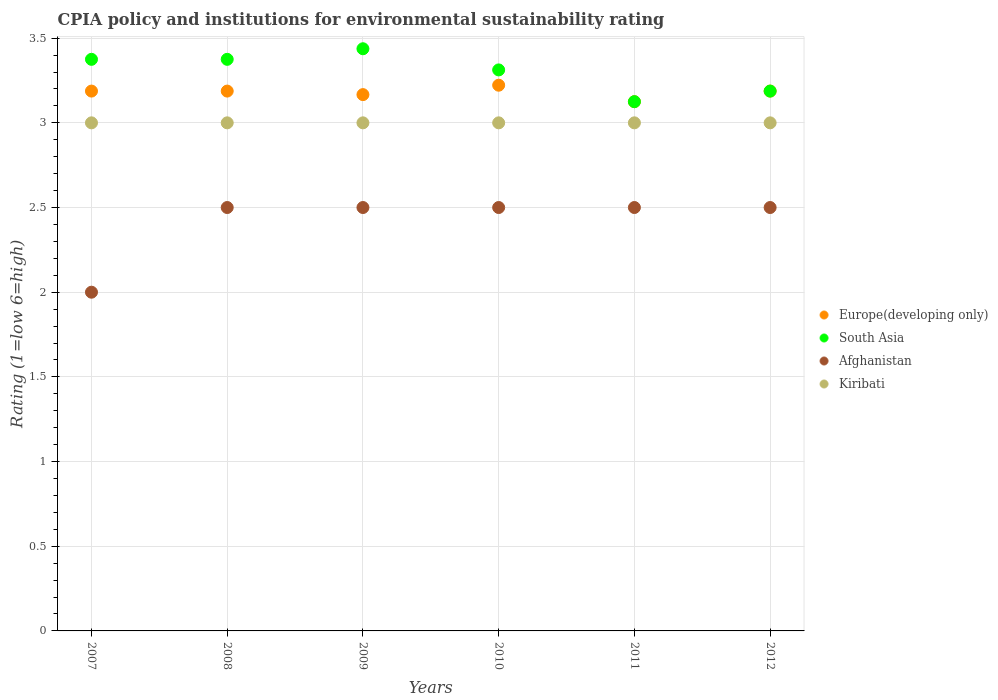What is the CPIA rating in South Asia in 2012?
Provide a succinct answer. 3.19. Across all years, what is the maximum CPIA rating in Afghanistan?
Provide a short and direct response. 2.5. Across all years, what is the minimum CPIA rating in South Asia?
Give a very brief answer. 3.12. In which year was the CPIA rating in South Asia maximum?
Keep it short and to the point. 2009. In which year was the CPIA rating in Kiribati minimum?
Your answer should be compact. 2007. What is the total CPIA rating in Europe(developing only) in the graph?
Your response must be concise. 19.08. What is the difference between the CPIA rating in South Asia in 2008 and that in 2010?
Ensure brevity in your answer.  0.06. What is the difference between the CPIA rating in South Asia in 2011 and the CPIA rating in Europe(developing only) in 2012?
Your answer should be compact. -0.06. What is the average CPIA rating in Europe(developing only) per year?
Provide a succinct answer. 3.18. What is the ratio of the CPIA rating in South Asia in 2010 to that in 2011?
Provide a succinct answer. 1.06. In how many years, is the CPIA rating in Afghanistan greater than the average CPIA rating in Afghanistan taken over all years?
Keep it short and to the point. 5. Is it the case that in every year, the sum of the CPIA rating in Europe(developing only) and CPIA rating in South Asia  is greater than the sum of CPIA rating in Afghanistan and CPIA rating in Kiribati?
Your response must be concise. Yes. Is it the case that in every year, the sum of the CPIA rating in Europe(developing only) and CPIA rating in Kiribati  is greater than the CPIA rating in Afghanistan?
Provide a succinct answer. Yes. Does the CPIA rating in Afghanistan monotonically increase over the years?
Your answer should be very brief. No. Is the CPIA rating in South Asia strictly greater than the CPIA rating in Europe(developing only) over the years?
Your response must be concise. No. Is the CPIA rating in Kiribati strictly less than the CPIA rating in South Asia over the years?
Your answer should be very brief. Yes. What is the difference between two consecutive major ticks on the Y-axis?
Make the answer very short. 0.5. Are the values on the major ticks of Y-axis written in scientific E-notation?
Your response must be concise. No. Where does the legend appear in the graph?
Your answer should be very brief. Center right. What is the title of the graph?
Offer a very short reply. CPIA policy and institutions for environmental sustainability rating. What is the label or title of the X-axis?
Give a very brief answer. Years. What is the label or title of the Y-axis?
Make the answer very short. Rating (1=low 6=high). What is the Rating (1=low 6=high) in Europe(developing only) in 2007?
Your response must be concise. 3.19. What is the Rating (1=low 6=high) of South Asia in 2007?
Provide a short and direct response. 3.38. What is the Rating (1=low 6=high) in Afghanistan in 2007?
Provide a short and direct response. 2. What is the Rating (1=low 6=high) in Kiribati in 2007?
Offer a very short reply. 3. What is the Rating (1=low 6=high) of Europe(developing only) in 2008?
Your answer should be very brief. 3.19. What is the Rating (1=low 6=high) in South Asia in 2008?
Make the answer very short. 3.38. What is the Rating (1=low 6=high) in Kiribati in 2008?
Provide a short and direct response. 3. What is the Rating (1=low 6=high) in Europe(developing only) in 2009?
Your answer should be compact. 3.17. What is the Rating (1=low 6=high) in South Asia in 2009?
Your response must be concise. 3.44. What is the Rating (1=low 6=high) of Kiribati in 2009?
Offer a very short reply. 3. What is the Rating (1=low 6=high) in Europe(developing only) in 2010?
Offer a terse response. 3.22. What is the Rating (1=low 6=high) of South Asia in 2010?
Keep it short and to the point. 3.31. What is the Rating (1=low 6=high) in Europe(developing only) in 2011?
Keep it short and to the point. 3.12. What is the Rating (1=low 6=high) in South Asia in 2011?
Your response must be concise. 3.12. What is the Rating (1=low 6=high) in Afghanistan in 2011?
Provide a succinct answer. 2.5. What is the Rating (1=low 6=high) in Kiribati in 2011?
Provide a short and direct response. 3. What is the Rating (1=low 6=high) of Europe(developing only) in 2012?
Offer a terse response. 3.19. What is the Rating (1=low 6=high) in South Asia in 2012?
Offer a very short reply. 3.19. What is the Rating (1=low 6=high) in Kiribati in 2012?
Ensure brevity in your answer.  3. Across all years, what is the maximum Rating (1=low 6=high) in Europe(developing only)?
Give a very brief answer. 3.22. Across all years, what is the maximum Rating (1=low 6=high) of South Asia?
Ensure brevity in your answer.  3.44. Across all years, what is the maximum Rating (1=low 6=high) of Kiribati?
Make the answer very short. 3. Across all years, what is the minimum Rating (1=low 6=high) of Europe(developing only)?
Ensure brevity in your answer.  3.12. Across all years, what is the minimum Rating (1=low 6=high) of South Asia?
Give a very brief answer. 3.12. What is the total Rating (1=low 6=high) of Europe(developing only) in the graph?
Keep it short and to the point. 19.08. What is the total Rating (1=low 6=high) in South Asia in the graph?
Offer a very short reply. 19.81. What is the difference between the Rating (1=low 6=high) of Europe(developing only) in 2007 and that in 2008?
Give a very brief answer. 0. What is the difference between the Rating (1=low 6=high) in South Asia in 2007 and that in 2008?
Provide a succinct answer. 0. What is the difference between the Rating (1=low 6=high) in Afghanistan in 2007 and that in 2008?
Provide a short and direct response. -0.5. What is the difference between the Rating (1=low 6=high) of Kiribati in 2007 and that in 2008?
Provide a short and direct response. 0. What is the difference between the Rating (1=low 6=high) of Europe(developing only) in 2007 and that in 2009?
Keep it short and to the point. 0.02. What is the difference between the Rating (1=low 6=high) of South Asia in 2007 and that in 2009?
Ensure brevity in your answer.  -0.06. What is the difference between the Rating (1=low 6=high) of Kiribati in 2007 and that in 2009?
Offer a terse response. 0. What is the difference between the Rating (1=low 6=high) of Europe(developing only) in 2007 and that in 2010?
Offer a terse response. -0.03. What is the difference between the Rating (1=low 6=high) in South Asia in 2007 and that in 2010?
Offer a very short reply. 0.06. What is the difference between the Rating (1=low 6=high) in Kiribati in 2007 and that in 2010?
Keep it short and to the point. 0. What is the difference between the Rating (1=low 6=high) of Europe(developing only) in 2007 and that in 2011?
Offer a terse response. 0.06. What is the difference between the Rating (1=low 6=high) of South Asia in 2007 and that in 2012?
Offer a terse response. 0.19. What is the difference between the Rating (1=low 6=high) of Afghanistan in 2007 and that in 2012?
Offer a terse response. -0.5. What is the difference between the Rating (1=low 6=high) of Kiribati in 2007 and that in 2012?
Offer a very short reply. 0. What is the difference between the Rating (1=low 6=high) in Europe(developing only) in 2008 and that in 2009?
Your answer should be very brief. 0.02. What is the difference between the Rating (1=low 6=high) of South Asia in 2008 and that in 2009?
Offer a terse response. -0.06. What is the difference between the Rating (1=low 6=high) in Europe(developing only) in 2008 and that in 2010?
Your answer should be very brief. -0.03. What is the difference between the Rating (1=low 6=high) in South Asia in 2008 and that in 2010?
Your response must be concise. 0.06. What is the difference between the Rating (1=low 6=high) of Kiribati in 2008 and that in 2010?
Your response must be concise. 0. What is the difference between the Rating (1=low 6=high) in Europe(developing only) in 2008 and that in 2011?
Keep it short and to the point. 0.06. What is the difference between the Rating (1=low 6=high) of Kiribati in 2008 and that in 2011?
Give a very brief answer. 0. What is the difference between the Rating (1=low 6=high) of Europe(developing only) in 2008 and that in 2012?
Keep it short and to the point. 0. What is the difference between the Rating (1=low 6=high) in South Asia in 2008 and that in 2012?
Give a very brief answer. 0.19. What is the difference between the Rating (1=low 6=high) in Kiribati in 2008 and that in 2012?
Your answer should be compact. 0. What is the difference between the Rating (1=low 6=high) of Europe(developing only) in 2009 and that in 2010?
Your response must be concise. -0.06. What is the difference between the Rating (1=low 6=high) in South Asia in 2009 and that in 2010?
Your answer should be very brief. 0.12. What is the difference between the Rating (1=low 6=high) in Kiribati in 2009 and that in 2010?
Make the answer very short. 0. What is the difference between the Rating (1=low 6=high) in Europe(developing only) in 2009 and that in 2011?
Ensure brevity in your answer.  0.04. What is the difference between the Rating (1=low 6=high) in South Asia in 2009 and that in 2011?
Offer a very short reply. 0.31. What is the difference between the Rating (1=low 6=high) in Kiribati in 2009 and that in 2011?
Your answer should be very brief. 0. What is the difference between the Rating (1=low 6=high) of Europe(developing only) in 2009 and that in 2012?
Offer a very short reply. -0.02. What is the difference between the Rating (1=low 6=high) in Afghanistan in 2009 and that in 2012?
Provide a succinct answer. 0. What is the difference between the Rating (1=low 6=high) in Europe(developing only) in 2010 and that in 2011?
Offer a very short reply. 0.1. What is the difference between the Rating (1=low 6=high) in South Asia in 2010 and that in 2011?
Your response must be concise. 0.19. What is the difference between the Rating (1=low 6=high) in Kiribati in 2010 and that in 2011?
Make the answer very short. 0. What is the difference between the Rating (1=low 6=high) in Europe(developing only) in 2010 and that in 2012?
Provide a short and direct response. 0.03. What is the difference between the Rating (1=low 6=high) of South Asia in 2010 and that in 2012?
Provide a short and direct response. 0.12. What is the difference between the Rating (1=low 6=high) in Kiribati in 2010 and that in 2012?
Keep it short and to the point. 0. What is the difference between the Rating (1=low 6=high) of Europe(developing only) in 2011 and that in 2012?
Provide a short and direct response. -0.06. What is the difference between the Rating (1=low 6=high) in South Asia in 2011 and that in 2012?
Provide a succinct answer. -0.06. What is the difference between the Rating (1=low 6=high) in Europe(developing only) in 2007 and the Rating (1=low 6=high) in South Asia in 2008?
Give a very brief answer. -0.19. What is the difference between the Rating (1=low 6=high) of Europe(developing only) in 2007 and the Rating (1=low 6=high) of Afghanistan in 2008?
Your answer should be very brief. 0.69. What is the difference between the Rating (1=low 6=high) in Europe(developing only) in 2007 and the Rating (1=low 6=high) in Kiribati in 2008?
Make the answer very short. 0.19. What is the difference between the Rating (1=low 6=high) of Afghanistan in 2007 and the Rating (1=low 6=high) of Kiribati in 2008?
Offer a very short reply. -1. What is the difference between the Rating (1=low 6=high) in Europe(developing only) in 2007 and the Rating (1=low 6=high) in South Asia in 2009?
Provide a short and direct response. -0.25. What is the difference between the Rating (1=low 6=high) of Europe(developing only) in 2007 and the Rating (1=low 6=high) of Afghanistan in 2009?
Your response must be concise. 0.69. What is the difference between the Rating (1=low 6=high) in Europe(developing only) in 2007 and the Rating (1=low 6=high) in Kiribati in 2009?
Offer a very short reply. 0.19. What is the difference between the Rating (1=low 6=high) in Afghanistan in 2007 and the Rating (1=low 6=high) in Kiribati in 2009?
Offer a very short reply. -1. What is the difference between the Rating (1=low 6=high) of Europe(developing only) in 2007 and the Rating (1=low 6=high) of South Asia in 2010?
Offer a very short reply. -0.12. What is the difference between the Rating (1=low 6=high) of Europe(developing only) in 2007 and the Rating (1=low 6=high) of Afghanistan in 2010?
Your answer should be very brief. 0.69. What is the difference between the Rating (1=low 6=high) in Europe(developing only) in 2007 and the Rating (1=low 6=high) in Kiribati in 2010?
Give a very brief answer. 0.19. What is the difference between the Rating (1=low 6=high) of South Asia in 2007 and the Rating (1=low 6=high) of Afghanistan in 2010?
Provide a succinct answer. 0.88. What is the difference between the Rating (1=low 6=high) in South Asia in 2007 and the Rating (1=low 6=high) in Kiribati in 2010?
Your response must be concise. 0.38. What is the difference between the Rating (1=low 6=high) of Europe(developing only) in 2007 and the Rating (1=low 6=high) of South Asia in 2011?
Provide a succinct answer. 0.06. What is the difference between the Rating (1=low 6=high) in Europe(developing only) in 2007 and the Rating (1=low 6=high) in Afghanistan in 2011?
Offer a very short reply. 0.69. What is the difference between the Rating (1=low 6=high) of Europe(developing only) in 2007 and the Rating (1=low 6=high) of Kiribati in 2011?
Offer a terse response. 0.19. What is the difference between the Rating (1=low 6=high) in South Asia in 2007 and the Rating (1=low 6=high) in Afghanistan in 2011?
Your response must be concise. 0.88. What is the difference between the Rating (1=low 6=high) in Europe(developing only) in 2007 and the Rating (1=low 6=high) in Afghanistan in 2012?
Offer a terse response. 0.69. What is the difference between the Rating (1=low 6=high) of Europe(developing only) in 2007 and the Rating (1=low 6=high) of Kiribati in 2012?
Offer a very short reply. 0.19. What is the difference between the Rating (1=low 6=high) in South Asia in 2007 and the Rating (1=low 6=high) in Afghanistan in 2012?
Make the answer very short. 0.88. What is the difference between the Rating (1=low 6=high) of Afghanistan in 2007 and the Rating (1=low 6=high) of Kiribati in 2012?
Offer a very short reply. -1. What is the difference between the Rating (1=low 6=high) of Europe(developing only) in 2008 and the Rating (1=low 6=high) of South Asia in 2009?
Provide a succinct answer. -0.25. What is the difference between the Rating (1=low 6=high) of Europe(developing only) in 2008 and the Rating (1=low 6=high) of Afghanistan in 2009?
Offer a very short reply. 0.69. What is the difference between the Rating (1=low 6=high) in Europe(developing only) in 2008 and the Rating (1=low 6=high) in Kiribati in 2009?
Your answer should be very brief. 0.19. What is the difference between the Rating (1=low 6=high) of South Asia in 2008 and the Rating (1=low 6=high) of Kiribati in 2009?
Provide a short and direct response. 0.38. What is the difference between the Rating (1=low 6=high) in Europe(developing only) in 2008 and the Rating (1=low 6=high) in South Asia in 2010?
Your answer should be very brief. -0.12. What is the difference between the Rating (1=low 6=high) of Europe(developing only) in 2008 and the Rating (1=low 6=high) of Afghanistan in 2010?
Ensure brevity in your answer.  0.69. What is the difference between the Rating (1=low 6=high) of Europe(developing only) in 2008 and the Rating (1=low 6=high) of Kiribati in 2010?
Your response must be concise. 0.19. What is the difference between the Rating (1=low 6=high) in South Asia in 2008 and the Rating (1=low 6=high) in Afghanistan in 2010?
Provide a short and direct response. 0.88. What is the difference between the Rating (1=low 6=high) of Afghanistan in 2008 and the Rating (1=low 6=high) of Kiribati in 2010?
Provide a succinct answer. -0.5. What is the difference between the Rating (1=low 6=high) in Europe(developing only) in 2008 and the Rating (1=low 6=high) in South Asia in 2011?
Ensure brevity in your answer.  0.06. What is the difference between the Rating (1=low 6=high) in Europe(developing only) in 2008 and the Rating (1=low 6=high) in Afghanistan in 2011?
Ensure brevity in your answer.  0.69. What is the difference between the Rating (1=low 6=high) in Europe(developing only) in 2008 and the Rating (1=low 6=high) in Kiribati in 2011?
Give a very brief answer. 0.19. What is the difference between the Rating (1=low 6=high) in South Asia in 2008 and the Rating (1=low 6=high) in Afghanistan in 2011?
Your answer should be very brief. 0.88. What is the difference between the Rating (1=low 6=high) of South Asia in 2008 and the Rating (1=low 6=high) of Kiribati in 2011?
Offer a terse response. 0.38. What is the difference between the Rating (1=low 6=high) in Europe(developing only) in 2008 and the Rating (1=low 6=high) in Afghanistan in 2012?
Give a very brief answer. 0.69. What is the difference between the Rating (1=low 6=high) in Europe(developing only) in 2008 and the Rating (1=low 6=high) in Kiribati in 2012?
Give a very brief answer. 0.19. What is the difference between the Rating (1=low 6=high) of South Asia in 2008 and the Rating (1=low 6=high) of Afghanistan in 2012?
Offer a very short reply. 0.88. What is the difference between the Rating (1=low 6=high) in South Asia in 2008 and the Rating (1=low 6=high) in Kiribati in 2012?
Keep it short and to the point. 0.38. What is the difference between the Rating (1=low 6=high) in Europe(developing only) in 2009 and the Rating (1=low 6=high) in South Asia in 2010?
Provide a succinct answer. -0.15. What is the difference between the Rating (1=low 6=high) in Europe(developing only) in 2009 and the Rating (1=low 6=high) in Kiribati in 2010?
Make the answer very short. 0.17. What is the difference between the Rating (1=low 6=high) of South Asia in 2009 and the Rating (1=low 6=high) of Afghanistan in 2010?
Your answer should be very brief. 0.94. What is the difference between the Rating (1=low 6=high) of South Asia in 2009 and the Rating (1=low 6=high) of Kiribati in 2010?
Provide a short and direct response. 0.44. What is the difference between the Rating (1=low 6=high) of Europe(developing only) in 2009 and the Rating (1=low 6=high) of South Asia in 2011?
Provide a succinct answer. 0.04. What is the difference between the Rating (1=low 6=high) of Europe(developing only) in 2009 and the Rating (1=low 6=high) of Afghanistan in 2011?
Your response must be concise. 0.67. What is the difference between the Rating (1=low 6=high) of Europe(developing only) in 2009 and the Rating (1=low 6=high) of Kiribati in 2011?
Provide a short and direct response. 0.17. What is the difference between the Rating (1=low 6=high) of South Asia in 2009 and the Rating (1=low 6=high) of Afghanistan in 2011?
Provide a short and direct response. 0.94. What is the difference between the Rating (1=low 6=high) in South Asia in 2009 and the Rating (1=low 6=high) in Kiribati in 2011?
Give a very brief answer. 0.44. What is the difference between the Rating (1=low 6=high) in Europe(developing only) in 2009 and the Rating (1=low 6=high) in South Asia in 2012?
Offer a very short reply. -0.02. What is the difference between the Rating (1=low 6=high) in Europe(developing only) in 2009 and the Rating (1=low 6=high) in Afghanistan in 2012?
Keep it short and to the point. 0.67. What is the difference between the Rating (1=low 6=high) in Europe(developing only) in 2009 and the Rating (1=low 6=high) in Kiribati in 2012?
Your response must be concise. 0.17. What is the difference between the Rating (1=low 6=high) of South Asia in 2009 and the Rating (1=low 6=high) of Kiribati in 2012?
Offer a terse response. 0.44. What is the difference between the Rating (1=low 6=high) in Europe(developing only) in 2010 and the Rating (1=low 6=high) in South Asia in 2011?
Offer a very short reply. 0.1. What is the difference between the Rating (1=low 6=high) of Europe(developing only) in 2010 and the Rating (1=low 6=high) of Afghanistan in 2011?
Your answer should be compact. 0.72. What is the difference between the Rating (1=low 6=high) in Europe(developing only) in 2010 and the Rating (1=low 6=high) in Kiribati in 2011?
Your answer should be compact. 0.22. What is the difference between the Rating (1=low 6=high) of South Asia in 2010 and the Rating (1=low 6=high) of Afghanistan in 2011?
Offer a very short reply. 0.81. What is the difference between the Rating (1=low 6=high) of South Asia in 2010 and the Rating (1=low 6=high) of Kiribati in 2011?
Your response must be concise. 0.31. What is the difference between the Rating (1=low 6=high) in Europe(developing only) in 2010 and the Rating (1=low 6=high) in South Asia in 2012?
Your answer should be very brief. 0.03. What is the difference between the Rating (1=low 6=high) in Europe(developing only) in 2010 and the Rating (1=low 6=high) in Afghanistan in 2012?
Provide a short and direct response. 0.72. What is the difference between the Rating (1=low 6=high) in Europe(developing only) in 2010 and the Rating (1=low 6=high) in Kiribati in 2012?
Provide a succinct answer. 0.22. What is the difference between the Rating (1=low 6=high) of South Asia in 2010 and the Rating (1=low 6=high) of Afghanistan in 2012?
Offer a very short reply. 0.81. What is the difference between the Rating (1=low 6=high) of South Asia in 2010 and the Rating (1=low 6=high) of Kiribati in 2012?
Ensure brevity in your answer.  0.31. What is the difference between the Rating (1=low 6=high) in Europe(developing only) in 2011 and the Rating (1=low 6=high) in South Asia in 2012?
Your response must be concise. -0.06. What is the difference between the Rating (1=low 6=high) of South Asia in 2011 and the Rating (1=low 6=high) of Afghanistan in 2012?
Provide a short and direct response. 0.62. What is the average Rating (1=low 6=high) in Europe(developing only) per year?
Your answer should be very brief. 3.18. What is the average Rating (1=low 6=high) in South Asia per year?
Your answer should be very brief. 3.3. What is the average Rating (1=low 6=high) in Afghanistan per year?
Give a very brief answer. 2.42. In the year 2007, what is the difference between the Rating (1=low 6=high) in Europe(developing only) and Rating (1=low 6=high) in South Asia?
Your answer should be compact. -0.19. In the year 2007, what is the difference between the Rating (1=low 6=high) in Europe(developing only) and Rating (1=low 6=high) in Afghanistan?
Give a very brief answer. 1.19. In the year 2007, what is the difference between the Rating (1=low 6=high) of Europe(developing only) and Rating (1=low 6=high) of Kiribati?
Give a very brief answer. 0.19. In the year 2007, what is the difference between the Rating (1=low 6=high) in South Asia and Rating (1=low 6=high) in Afghanistan?
Offer a very short reply. 1.38. In the year 2008, what is the difference between the Rating (1=low 6=high) in Europe(developing only) and Rating (1=low 6=high) in South Asia?
Offer a terse response. -0.19. In the year 2008, what is the difference between the Rating (1=low 6=high) of Europe(developing only) and Rating (1=low 6=high) of Afghanistan?
Offer a terse response. 0.69. In the year 2008, what is the difference between the Rating (1=low 6=high) in Europe(developing only) and Rating (1=low 6=high) in Kiribati?
Make the answer very short. 0.19. In the year 2008, what is the difference between the Rating (1=low 6=high) in South Asia and Rating (1=low 6=high) in Afghanistan?
Keep it short and to the point. 0.88. In the year 2008, what is the difference between the Rating (1=low 6=high) of South Asia and Rating (1=low 6=high) of Kiribati?
Ensure brevity in your answer.  0.38. In the year 2008, what is the difference between the Rating (1=low 6=high) in Afghanistan and Rating (1=low 6=high) in Kiribati?
Keep it short and to the point. -0.5. In the year 2009, what is the difference between the Rating (1=low 6=high) of Europe(developing only) and Rating (1=low 6=high) of South Asia?
Offer a terse response. -0.27. In the year 2009, what is the difference between the Rating (1=low 6=high) of Europe(developing only) and Rating (1=low 6=high) of Afghanistan?
Your answer should be very brief. 0.67. In the year 2009, what is the difference between the Rating (1=low 6=high) of Europe(developing only) and Rating (1=low 6=high) of Kiribati?
Keep it short and to the point. 0.17. In the year 2009, what is the difference between the Rating (1=low 6=high) in South Asia and Rating (1=low 6=high) in Afghanistan?
Your answer should be compact. 0.94. In the year 2009, what is the difference between the Rating (1=low 6=high) in South Asia and Rating (1=low 6=high) in Kiribati?
Give a very brief answer. 0.44. In the year 2009, what is the difference between the Rating (1=low 6=high) in Afghanistan and Rating (1=low 6=high) in Kiribati?
Make the answer very short. -0.5. In the year 2010, what is the difference between the Rating (1=low 6=high) in Europe(developing only) and Rating (1=low 6=high) in South Asia?
Offer a terse response. -0.09. In the year 2010, what is the difference between the Rating (1=low 6=high) in Europe(developing only) and Rating (1=low 6=high) in Afghanistan?
Provide a short and direct response. 0.72. In the year 2010, what is the difference between the Rating (1=low 6=high) of Europe(developing only) and Rating (1=low 6=high) of Kiribati?
Your answer should be compact. 0.22. In the year 2010, what is the difference between the Rating (1=low 6=high) of South Asia and Rating (1=low 6=high) of Afghanistan?
Provide a short and direct response. 0.81. In the year 2010, what is the difference between the Rating (1=low 6=high) of South Asia and Rating (1=low 6=high) of Kiribati?
Your answer should be very brief. 0.31. In the year 2011, what is the difference between the Rating (1=low 6=high) in South Asia and Rating (1=low 6=high) in Kiribati?
Offer a very short reply. 0.12. In the year 2011, what is the difference between the Rating (1=low 6=high) in Afghanistan and Rating (1=low 6=high) in Kiribati?
Provide a succinct answer. -0.5. In the year 2012, what is the difference between the Rating (1=low 6=high) in Europe(developing only) and Rating (1=low 6=high) in Afghanistan?
Offer a very short reply. 0.69. In the year 2012, what is the difference between the Rating (1=low 6=high) of Europe(developing only) and Rating (1=low 6=high) of Kiribati?
Provide a short and direct response. 0.19. In the year 2012, what is the difference between the Rating (1=low 6=high) in South Asia and Rating (1=low 6=high) in Afghanistan?
Provide a short and direct response. 0.69. In the year 2012, what is the difference between the Rating (1=low 6=high) in South Asia and Rating (1=low 6=high) in Kiribati?
Provide a short and direct response. 0.19. In the year 2012, what is the difference between the Rating (1=low 6=high) of Afghanistan and Rating (1=low 6=high) of Kiribati?
Ensure brevity in your answer.  -0.5. What is the ratio of the Rating (1=low 6=high) in Europe(developing only) in 2007 to that in 2009?
Your response must be concise. 1.01. What is the ratio of the Rating (1=low 6=high) of South Asia in 2007 to that in 2009?
Your answer should be very brief. 0.98. What is the ratio of the Rating (1=low 6=high) in Europe(developing only) in 2007 to that in 2010?
Provide a short and direct response. 0.99. What is the ratio of the Rating (1=low 6=high) in South Asia in 2007 to that in 2010?
Keep it short and to the point. 1.02. What is the ratio of the Rating (1=low 6=high) in Europe(developing only) in 2007 to that in 2011?
Ensure brevity in your answer.  1.02. What is the ratio of the Rating (1=low 6=high) of Europe(developing only) in 2007 to that in 2012?
Give a very brief answer. 1. What is the ratio of the Rating (1=low 6=high) in South Asia in 2007 to that in 2012?
Offer a terse response. 1.06. What is the ratio of the Rating (1=low 6=high) in Europe(developing only) in 2008 to that in 2009?
Provide a short and direct response. 1.01. What is the ratio of the Rating (1=low 6=high) in South Asia in 2008 to that in 2009?
Give a very brief answer. 0.98. What is the ratio of the Rating (1=low 6=high) in Kiribati in 2008 to that in 2009?
Your response must be concise. 1. What is the ratio of the Rating (1=low 6=high) of Europe(developing only) in 2008 to that in 2010?
Provide a succinct answer. 0.99. What is the ratio of the Rating (1=low 6=high) of South Asia in 2008 to that in 2010?
Ensure brevity in your answer.  1.02. What is the ratio of the Rating (1=low 6=high) in Kiribati in 2008 to that in 2010?
Your answer should be very brief. 1. What is the ratio of the Rating (1=low 6=high) in Afghanistan in 2008 to that in 2011?
Your answer should be very brief. 1. What is the ratio of the Rating (1=low 6=high) of Kiribati in 2008 to that in 2011?
Your response must be concise. 1. What is the ratio of the Rating (1=low 6=high) of South Asia in 2008 to that in 2012?
Your answer should be compact. 1.06. What is the ratio of the Rating (1=low 6=high) of Europe(developing only) in 2009 to that in 2010?
Your response must be concise. 0.98. What is the ratio of the Rating (1=low 6=high) of South Asia in 2009 to that in 2010?
Give a very brief answer. 1.04. What is the ratio of the Rating (1=low 6=high) in Kiribati in 2009 to that in 2010?
Provide a succinct answer. 1. What is the ratio of the Rating (1=low 6=high) of Europe(developing only) in 2009 to that in 2011?
Give a very brief answer. 1.01. What is the ratio of the Rating (1=low 6=high) in South Asia in 2009 to that in 2012?
Provide a succinct answer. 1.08. What is the ratio of the Rating (1=low 6=high) in Afghanistan in 2009 to that in 2012?
Offer a terse response. 1. What is the ratio of the Rating (1=low 6=high) in Kiribati in 2009 to that in 2012?
Make the answer very short. 1. What is the ratio of the Rating (1=low 6=high) in Europe(developing only) in 2010 to that in 2011?
Your answer should be very brief. 1.03. What is the ratio of the Rating (1=low 6=high) of South Asia in 2010 to that in 2011?
Your answer should be compact. 1.06. What is the ratio of the Rating (1=low 6=high) in Kiribati in 2010 to that in 2011?
Keep it short and to the point. 1. What is the ratio of the Rating (1=low 6=high) in Europe(developing only) in 2010 to that in 2012?
Give a very brief answer. 1.01. What is the ratio of the Rating (1=low 6=high) in South Asia in 2010 to that in 2012?
Your answer should be compact. 1.04. What is the ratio of the Rating (1=low 6=high) in Kiribati in 2010 to that in 2012?
Give a very brief answer. 1. What is the ratio of the Rating (1=low 6=high) in Europe(developing only) in 2011 to that in 2012?
Your answer should be very brief. 0.98. What is the ratio of the Rating (1=low 6=high) of South Asia in 2011 to that in 2012?
Your response must be concise. 0.98. What is the ratio of the Rating (1=low 6=high) in Afghanistan in 2011 to that in 2012?
Make the answer very short. 1. What is the ratio of the Rating (1=low 6=high) of Kiribati in 2011 to that in 2012?
Provide a succinct answer. 1. What is the difference between the highest and the second highest Rating (1=low 6=high) in Europe(developing only)?
Make the answer very short. 0.03. What is the difference between the highest and the second highest Rating (1=low 6=high) of South Asia?
Ensure brevity in your answer.  0.06. What is the difference between the highest and the second highest Rating (1=low 6=high) of Afghanistan?
Keep it short and to the point. 0. What is the difference between the highest and the lowest Rating (1=low 6=high) of Europe(developing only)?
Your answer should be very brief. 0.1. What is the difference between the highest and the lowest Rating (1=low 6=high) in South Asia?
Give a very brief answer. 0.31. What is the difference between the highest and the lowest Rating (1=low 6=high) of Afghanistan?
Provide a short and direct response. 0.5. What is the difference between the highest and the lowest Rating (1=low 6=high) in Kiribati?
Make the answer very short. 0. 